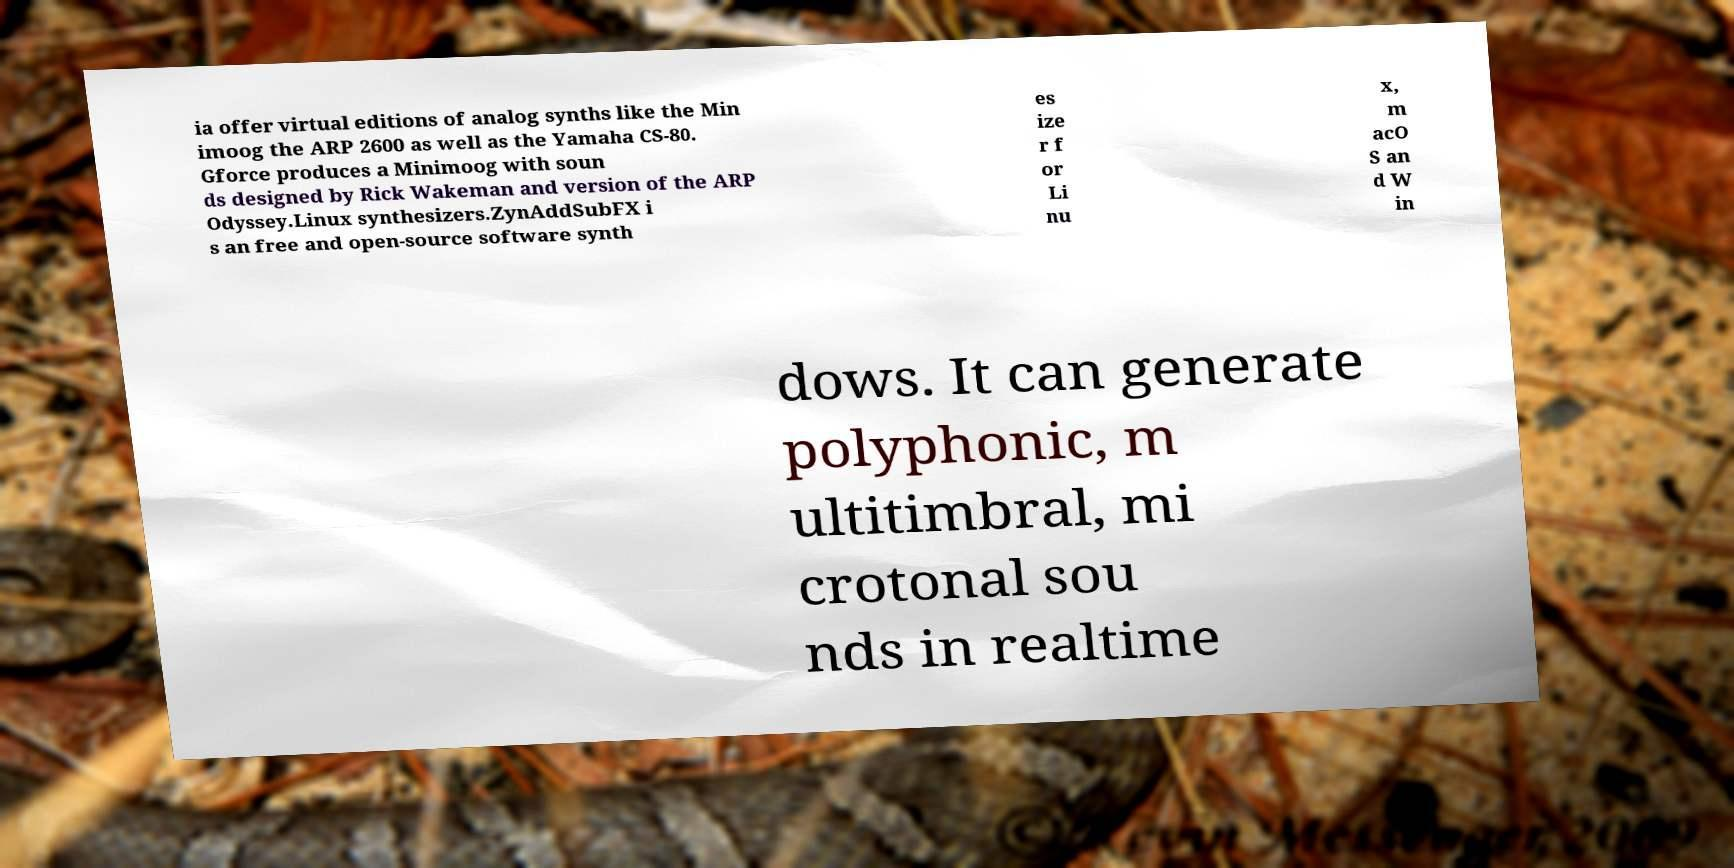What messages or text are displayed in this image? I need them in a readable, typed format. ia offer virtual editions of analog synths like the Min imoog the ARP 2600 as well as the Yamaha CS-80. Gforce produces a Minimoog with soun ds designed by Rick Wakeman and version of the ARP Odyssey.Linux synthesizers.ZynAddSubFX i s an free and open-source software synth es ize r f or Li nu x, m acO S an d W in dows. It can generate polyphonic, m ultitimbral, mi crotonal sou nds in realtime 